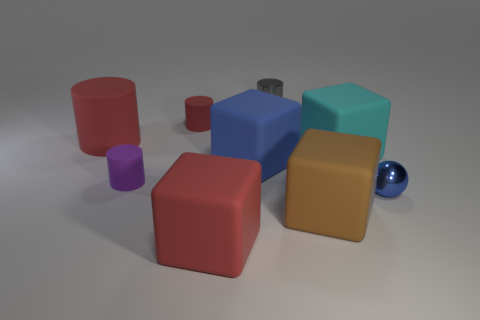Subtract 1 cylinders. How many cylinders are left? 3 Add 1 red matte cubes. How many objects exist? 10 Subtract all balls. How many objects are left? 8 Subtract 0 yellow cylinders. How many objects are left? 9 Subtract all large brown matte spheres. Subtract all small gray shiny cylinders. How many objects are left? 8 Add 6 big blue matte objects. How many big blue matte objects are left? 7 Add 1 large purple metal balls. How many large purple metal balls exist? 1 